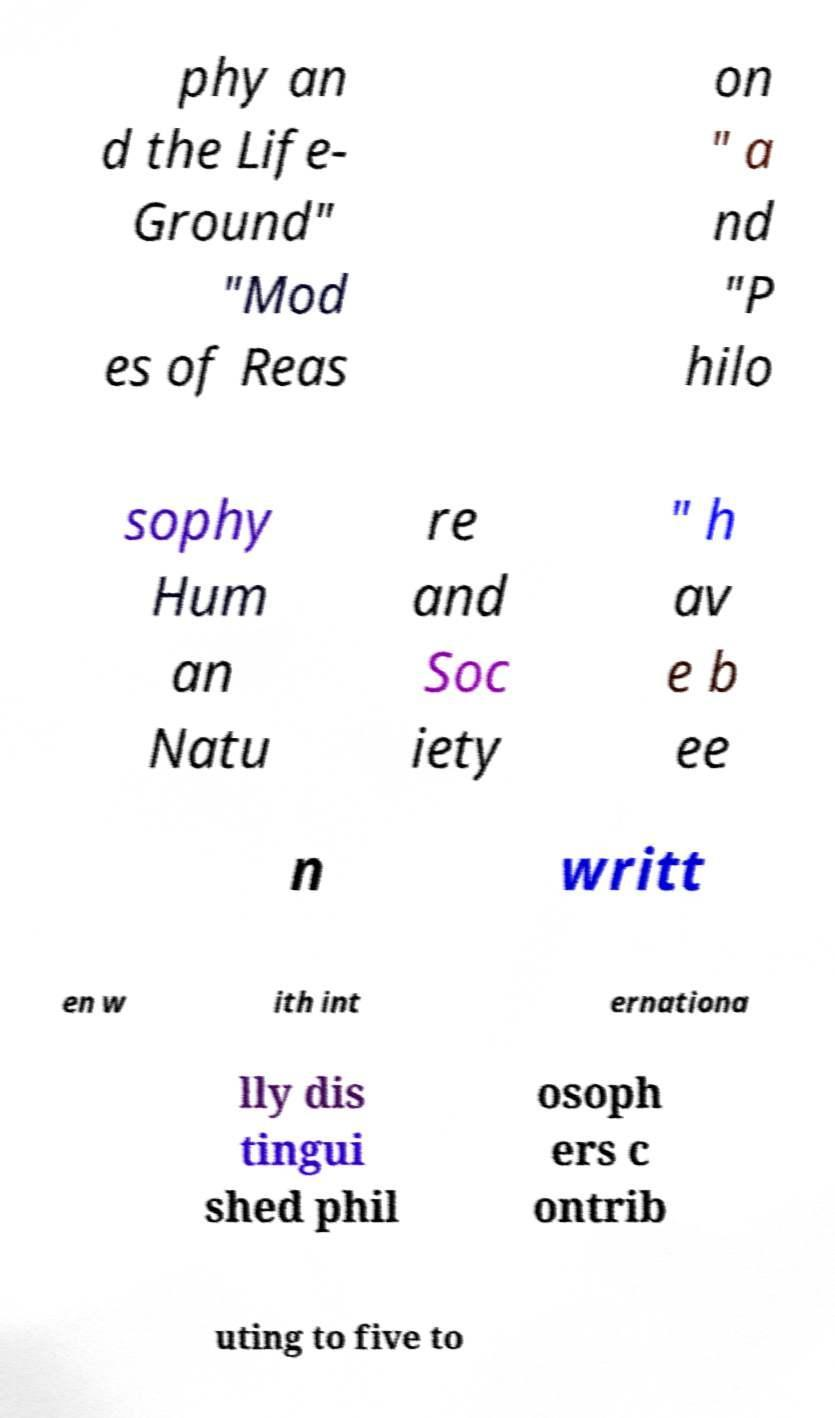Can you accurately transcribe the text from the provided image for me? phy an d the Life- Ground" "Mod es of Reas on " a nd "P hilo sophy Hum an Natu re and Soc iety " h av e b ee n writt en w ith int ernationa lly dis tingui shed phil osoph ers c ontrib uting to five to 